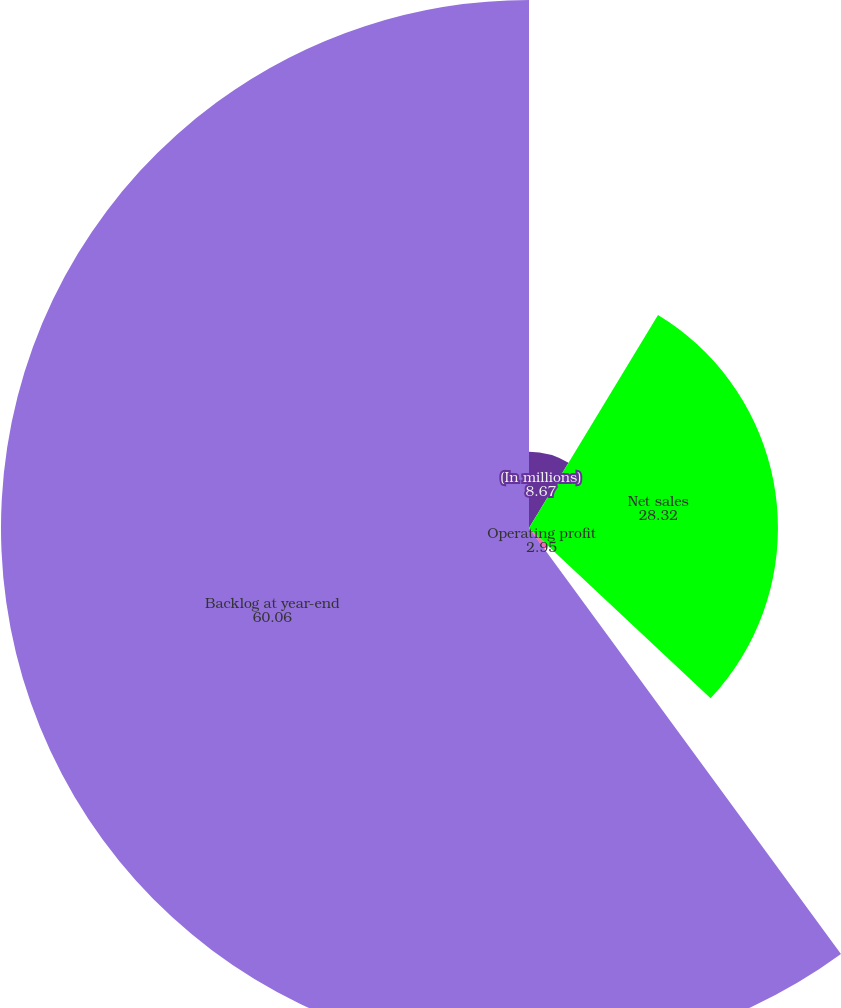Convert chart. <chart><loc_0><loc_0><loc_500><loc_500><pie_chart><fcel>(In millions)<fcel>Net sales<fcel>Operating profit<fcel>Backlog at year-end<nl><fcel>8.67%<fcel>28.32%<fcel>2.95%<fcel>60.06%<nl></chart> 